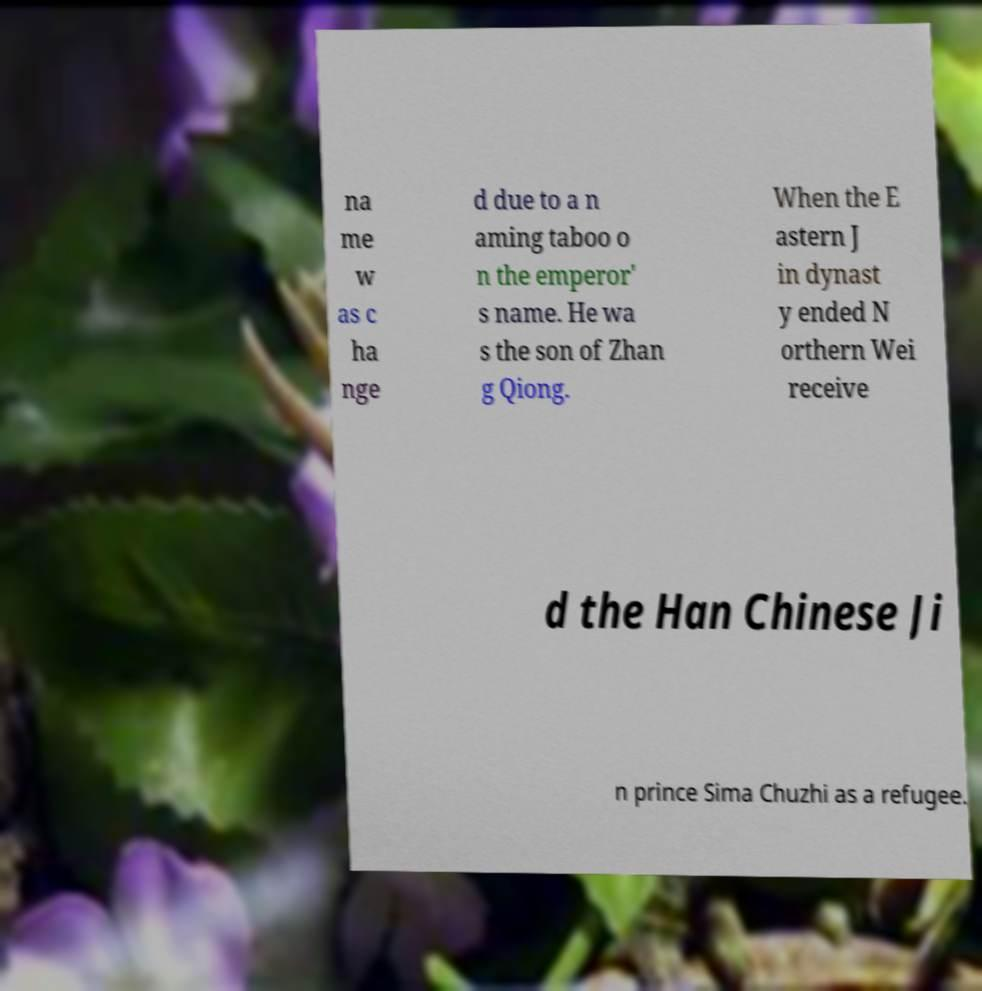Can you read and provide the text displayed in the image?This photo seems to have some interesting text. Can you extract and type it out for me? na me w as c ha nge d due to a n aming taboo o n the emperor' s name. He wa s the son of Zhan g Qiong. When the E astern J in dynast y ended N orthern Wei receive d the Han Chinese Ji n prince Sima Chuzhi as a refugee. 